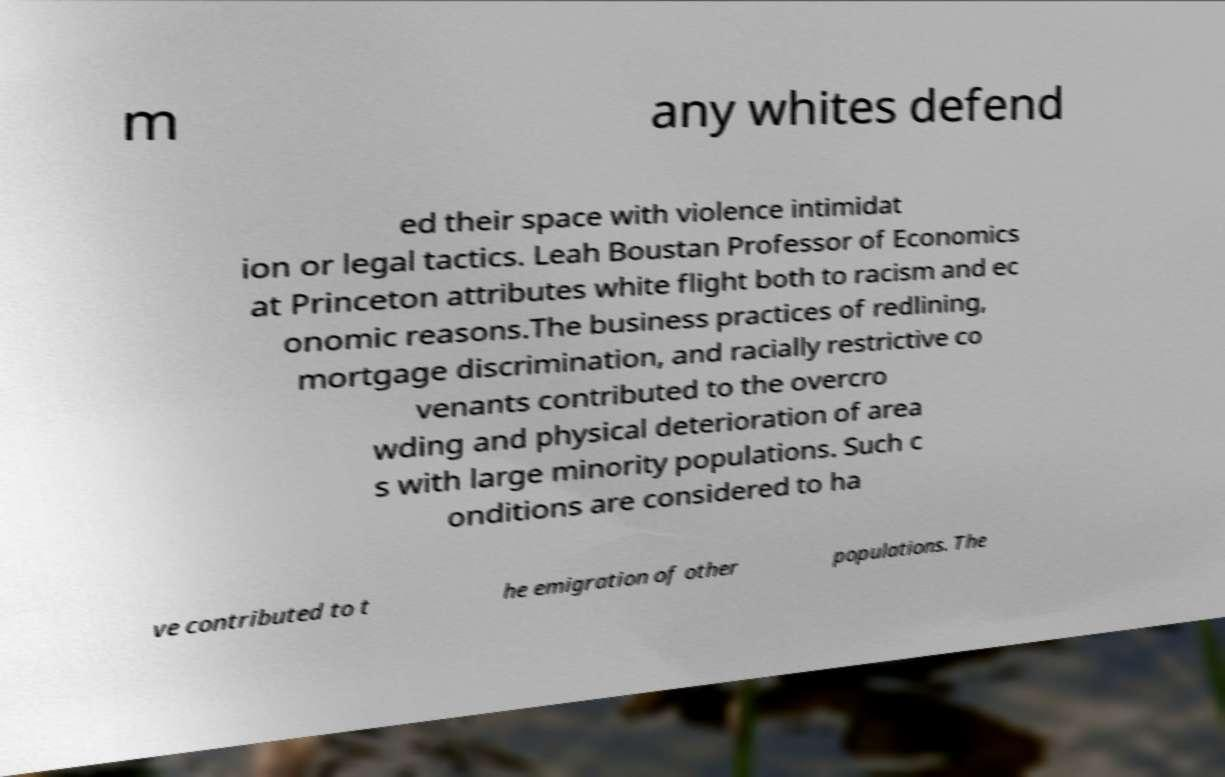For documentation purposes, I need the text within this image transcribed. Could you provide that? m any whites defend ed their space with violence intimidat ion or legal tactics. Leah Boustan Professor of Economics at Princeton attributes white flight both to racism and ec onomic reasons.The business practices of redlining, mortgage discrimination, and racially restrictive co venants contributed to the overcro wding and physical deterioration of area s with large minority populations. Such c onditions are considered to ha ve contributed to t he emigration of other populations. The 